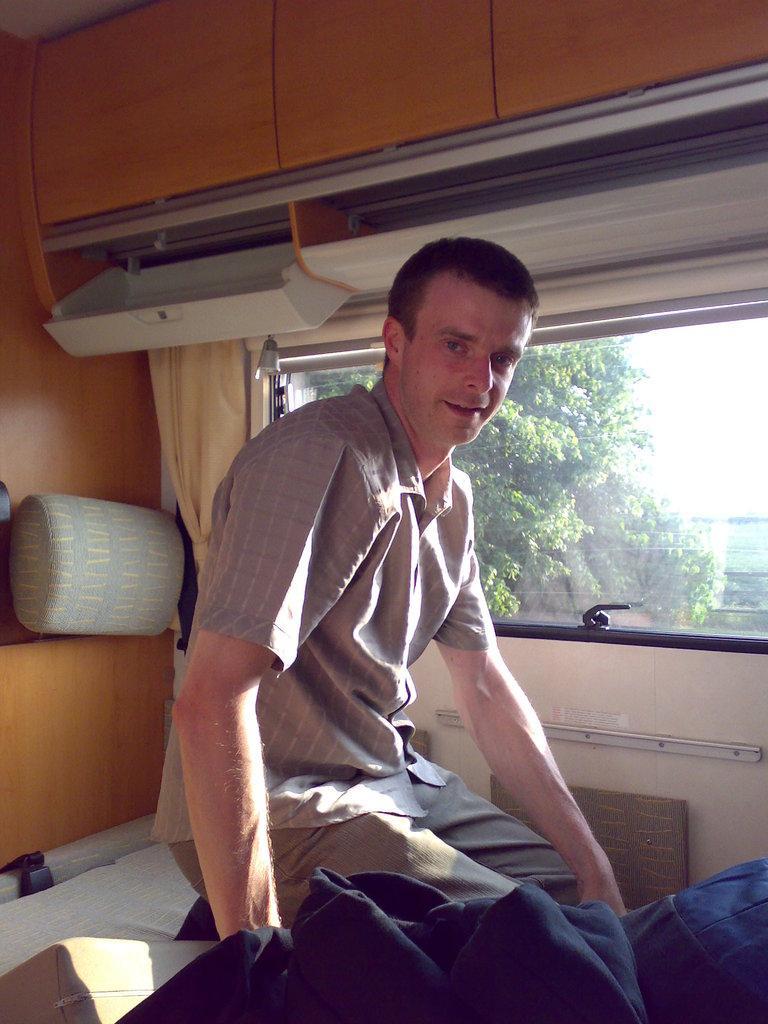Describe this image in one or two sentences. In this image we can see one man sitting on the bed in the vehicle, one glass window, one light, one blanket, some objects attached to the wall in the vehicle, one pillow, one curtain near to the window, there is the sky at the top, some trees are on the surface and some objects are on the surface. 